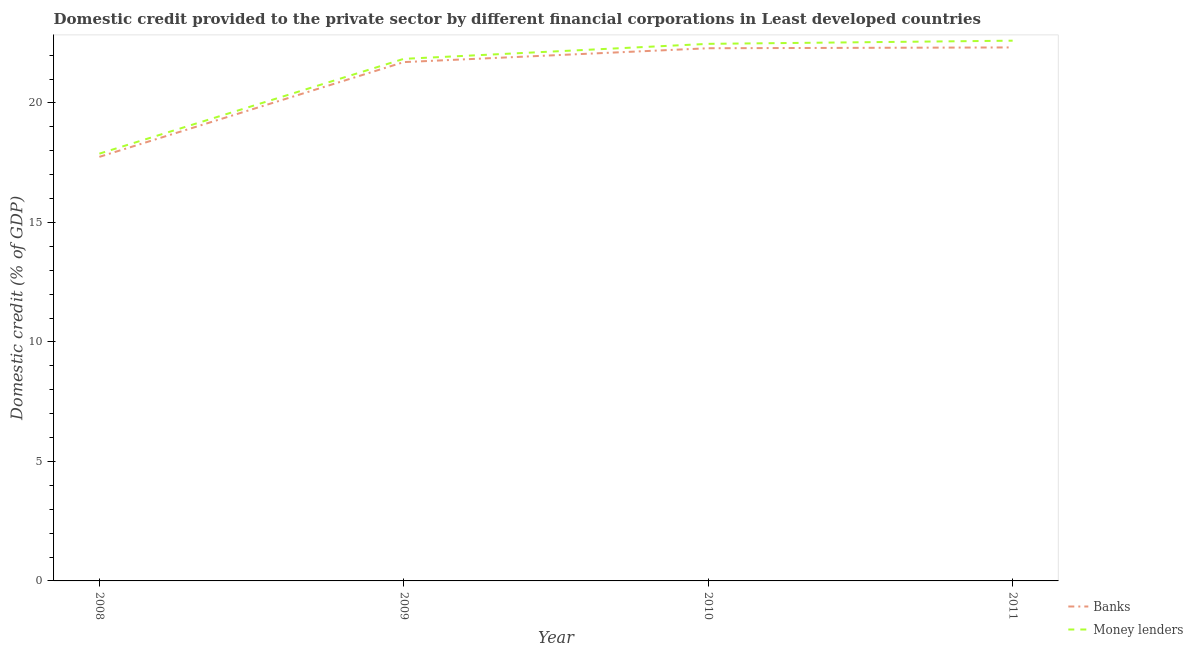How many different coloured lines are there?
Provide a succinct answer. 2. Does the line corresponding to domestic credit provided by banks intersect with the line corresponding to domestic credit provided by money lenders?
Offer a very short reply. No. What is the domestic credit provided by money lenders in 2009?
Make the answer very short. 21.85. Across all years, what is the maximum domestic credit provided by banks?
Provide a short and direct response. 22.32. Across all years, what is the minimum domestic credit provided by banks?
Your answer should be compact. 17.75. In which year was the domestic credit provided by money lenders maximum?
Ensure brevity in your answer.  2011. What is the total domestic credit provided by banks in the graph?
Offer a terse response. 84.07. What is the difference between the domestic credit provided by money lenders in 2009 and that in 2011?
Your answer should be very brief. -0.76. What is the difference between the domestic credit provided by money lenders in 2011 and the domestic credit provided by banks in 2009?
Make the answer very short. 0.9. What is the average domestic credit provided by money lenders per year?
Provide a short and direct response. 21.2. In the year 2008, what is the difference between the domestic credit provided by banks and domestic credit provided by money lenders?
Offer a very short reply. -0.13. What is the ratio of the domestic credit provided by money lenders in 2008 to that in 2009?
Your answer should be compact. 0.82. Is the domestic credit provided by money lenders in 2009 less than that in 2011?
Your answer should be compact. Yes. What is the difference between the highest and the second highest domestic credit provided by banks?
Make the answer very short. 0.03. What is the difference between the highest and the lowest domestic credit provided by banks?
Your answer should be very brief. 4.58. Is the sum of the domestic credit provided by money lenders in 2008 and 2010 greater than the maximum domestic credit provided by banks across all years?
Give a very brief answer. Yes. Does the domestic credit provided by money lenders monotonically increase over the years?
Keep it short and to the point. Yes. Is the domestic credit provided by banks strictly greater than the domestic credit provided by money lenders over the years?
Your response must be concise. No. Is the domestic credit provided by banks strictly less than the domestic credit provided by money lenders over the years?
Provide a short and direct response. Yes. How many lines are there?
Ensure brevity in your answer.  2. How many years are there in the graph?
Make the answer very short. 4. How are the legend labels stacked?
Give a very brief answer. Vertical. What is the title of the graph?
Offer a very short reply. Domestic credit provided to the private sector by different financial corporations in Least developed countries. Does "Revenue" appear as one of the legend labels in the graph?
Make the answer very short. No. What is the label or title of the X-axis?
Give a very brief answer. Year. What is the label or title of the Y-axis?
Ensure brevity in your answer.  Domestic credit (% of GDP). What is the Domestic credit (% of GDP) of Banks in 2008?
Offer a terse response. 17.75. What is the Domestic credit (% of GDP) of Money lenders in 2008?
Give a very brief answer. 17.88. What is the Domestic credit (% of GDP) in Banks in 2009?
Keep it short and to the point. 21.71. What is the Domestic credit (% of GDP) of Money lenders in 2009?
Provide a short and direct response. 21.85. What is the Domestic credit (% of GDP) in Banks in 2010?
Provide a succinct answer. 22.29. What is the Domestic credit (% of GDP) in Money lenders in 2010?
Your answer should be very brief. 22.47. What is the Domestic credit (% of GDP) of Banks in 2011?
Your answer should be very brief. 22.32. What is the Domestic credit (% of GDP) of Money lenders in 2011?
Offer a very short reply. 22.61. Across all years, what is the maximum Domestic credit (% of GDP) in Banks?
Offer a very short reply. 22.32. Across all years, what is the maximum Domestic credit (% of GDP) of Money lenders?
Offer a terse response. 22.61. Across all years, what is the minimum Domestic credit (% of GDP) in Banks?
Your answer should be compact. 17.75. Across all years, what is the minimum Domestic credit (% of GDP) in Money lenders?
Your answer should be very brief. 17.88. What is the total Domestic credit (% of GDP) in Banks in the graph?
Ensure brevity in your answer.  84.07. What is the total Domestic credit (% of GDP) in Money lenders in the graph?
Offer a terse response. 84.81. What is the difference between the Domestic credit (% of GDP) in Banks in 2008 and that in 2009?
Ensure brevity in your answer.  -3.96. What is the difference between the Domestic credit (% of GDP) of Money lenders in 2008 and that in 2009?
Provide a succinct answer. -3.97. What is the difference between the Domestic credit (% of GDP) in Banks in 2008 and that in 2010?
Ensure brevity in your answer.  -4.54. What is the difference between the Domestic credit (% of GDP) of Money lenders in 2008 and that in 2010?
Your answer should be very brief. -4.6. What is the difference between the Domestic credit (% of GDP) of Banks in 2008 and that in 2011?
Your answer should be very brief. -4.58. What is the difference between the Domestic credit (% of GDP) in Money lenders in 2008 and that in 2011?
Offer a very short reply. -4.73. What is the difference between the Domestic credit (% of GDP) of Banks in 2009 and that in 2010?
Provide a succinct answer. -0.58. What is the difference between the Domestic credit (% of GDP) of Money lenders in 2009 and that in 2010?
Offer a very short reply. -0.63. What is the difference between the Domestic credit (% of GDP) of Banks in 2009 and that in 2011?
Provide a succinct answer. -0.61. What is the difference between the Domestic credit (% of GDP) of Money lenders in 2009 and that in 2011?
Make the answer very short. -0.76. What is the difference between the Domestic credit (% of GDP) of Banks in 2010 and that in 2011?
Ensure brevity in your answer.  -0.03. What is the difference between the Domestic credit (% of GDP) in Money lenders in 2010 and that in 2011?
Make the answer very short. -0.13. What is the difference between the Domestic credit (% of GDP) of Banks in 2008 and the Domestic credit (% of GDP) of Money lenders in 2009?
Provide a succinct answer. -4.1. What is the difference between the Domestic credit (% of GDP) of Banks in 2008 and the Domestic credit (% of GDP) of Money lenders in 2010?
Provide a short and direct response. -4.73. What is the difference between the Domestic credit (% of GDP) of Banks in 2008 and the Domestic credit (% of GDP) of Money lenders in 2011?
Make the answer very short. -4.86. What is the difference between the Domestic credit (% of GDP) in Banks in 2009 and the Domestic credit (% of GDP) in Money lenders in 2010?
Make the answer very short. -0.76. What is the difference between the Domestic credit (% of GDP) in Banks in 2009 and the Domestic credit (% of GDP) in Money lenders in 2011?
Your response must be concise. -0.9. What is the difference between the Domestic credit (% of GDP) in Banks in 2010 and the Domestic credit (% of GDP) in Money lenders in 2011?
Offer a terse response. -0.32. What is the average Domestic credit (% of GDP) in Banks per year?
Ensure brevity in your answer.  21.02. What is the average Domestic credit (% of GDP) of Money lenders per year?
Your answer should be very brief. 21.2. In the year 2008, what is the difference between the Domestic credit (% of GDP) in Banks and Domestic credit (% of GDP) in Money lenders?
Your response must be concise. -0.13. In the year 2009, what is the difference between the Domestic credit (% of GDP) of Banks and Domestic credit (% of GDP) of Money lenders?
Your answer should be very brief. -0.14. In the year 2010, what is the difference between the Domestic credit (% of GDP) in Banks and Domestic credit (% of GDP) in Money lenders?
Provide a short and direct response. -0.18. In the year 2011, what is the difference between the Domestic credit (% of GDP) of Banks and Domestic credit (% of GDP) of Money lenders?
Provide a short and direct response. -0.28. What is the ratio of the Domestic credit (% of GDP) of Banks in 2008 to that in 2009?
Offer a very short reply. 0.82. What is the ratio of the Domestic credit (% of GDP) of Money lenders in 2008 to that in 2009?
Your answer should be compact. 0.82. What is the ratio of the Domestic credit (% of GDP) in Banks in 2008 to that in 2010?
Keep it short and to the point. 0.8. What is the ratio of the Domestic credit (% of GDP) in Money lenders in 2008 to that in 2010?
Your answer should be very brief. 0.8. What is the ratio of the Domestic credit (% of GDP) of Banks in 2008 to that in 2011?
Your answer should be compact. 0.79. What is the ratio of the Domestic credit (% of GDP) of Money lenders in 2008 to that in 2011?
Ensure brevity in your answer.  0.79. What is the ratio of the Domestic credit (% of GDP) in Money lenders in 2009 to that in 2010?
Make the answer very short. 0.97. What is the ratio of the Domestic credit (% of GDP) of Banks in 2009 to that in 2011?
Make the answer very short. 0.97. What is the ratio of the Domestic credit (% of GDP) in Money lenders in 2009 to that in 2011?
Provide a succinct answer. 0.97. What is the difference between the highest and the second highest Domestic credit (% of GDP) in Banks?
Your response must be concise. 0.03. What is the difference between the highest and the second highest Domestic credit (% of GDP) in Money lenders?
Offer a very short reply. 0.13. What is the difference between the highest and the lowest Domestic credit (% of GDP) of Banks?
Offer a very short reply. 4.58. What is the difference between the highest and the lowest Domestic credit (% of GDP) of Money lenders?
Offer a very short reply. 4.73. 